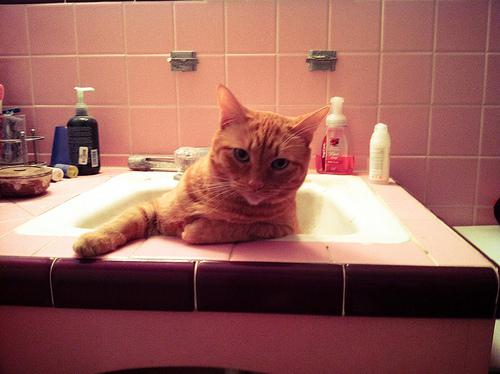Question: how many cats are there?
Choices:
A. Two.
B. Three.
C. One.
D. Four.
Answer with the letter. Answer: C Question: what color are the tiles?
Choices:
A. White.
B. Green.
C. Tan.
D. Blue.
Answer with the letter. Answer: C 